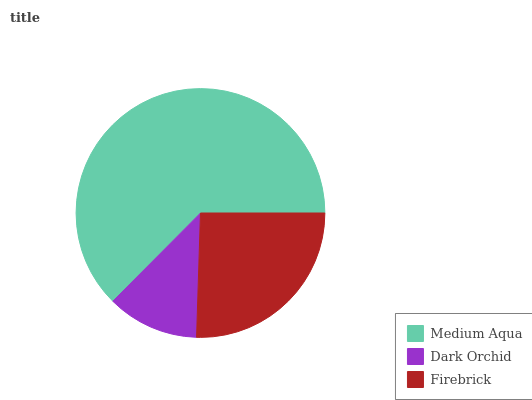Is Dark Orchid the minimum?
Answer yes or no. Yes. Is Medium Aqua the maximum?
Answer yes or no. Yes. Is Firebrick the minimum?
Answer yes or no. No. Is Firebrick the maximum?
Answer yes or no. No. Is Firebrick greater than Dark Orchid?
Answer yes or no. Yes. Is Dark Orchid less than Firebrick?
Answer yes or no. Yes. Is Dark Orchid greater than Firebrick?
Answer yes or no. No. Is Firebrick less than Dark Orchid?
Answer yes or no. No. Is Firebrick the high median?
Answer yes or no. Yes. Is Firebrick the low median?
Answer yes or no. Yes. Is Dark Orchid the high median?
Answer yes or no. No. Is Dark Orchid the low median?
Answer yes or no. No. 